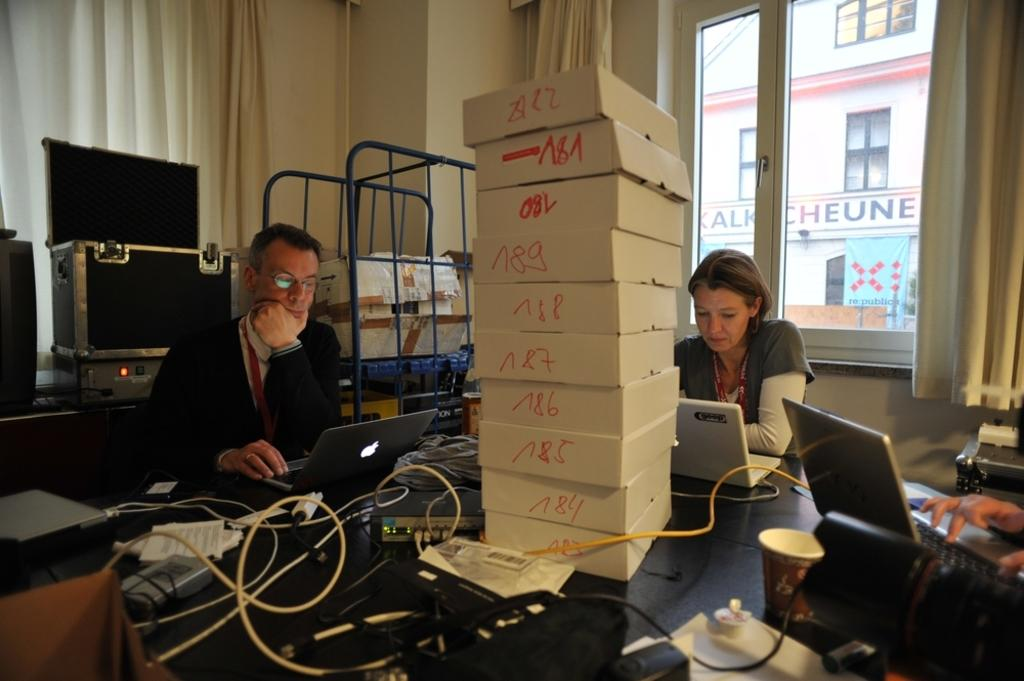<image>
Create a compact narrative representing the image presented. A man and a woman sitting in front of a pile of white boxes, on one of which the number 84 can be seen. 